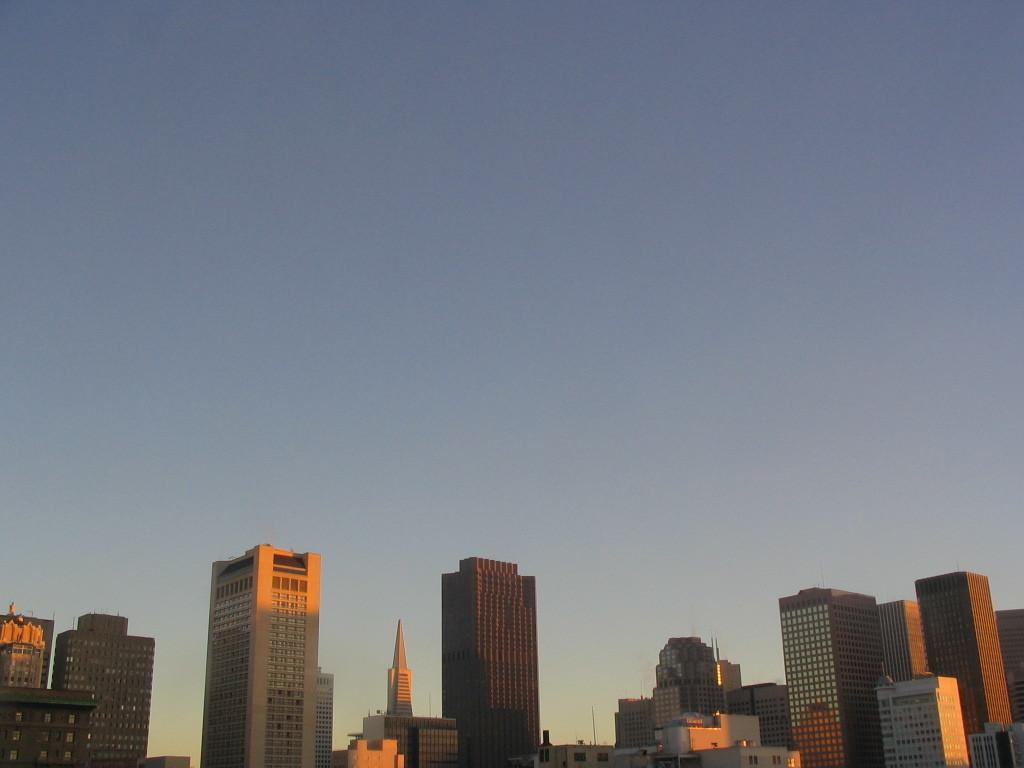What type of location is shown in the image? The image depicts a city. What structures can be seen in the city? There are buildings in the image. What else can be seen in the city besides buildings? There are poles in the image. What is visible at the top of the image? The sky is visible at the top of the image. How many giants are holding the poles in the image? There are no giants present in the image; it only shows poles and buildings. What type of kite can be seen flying in the sky in the image? There is no kite visible in the sky in the image. 